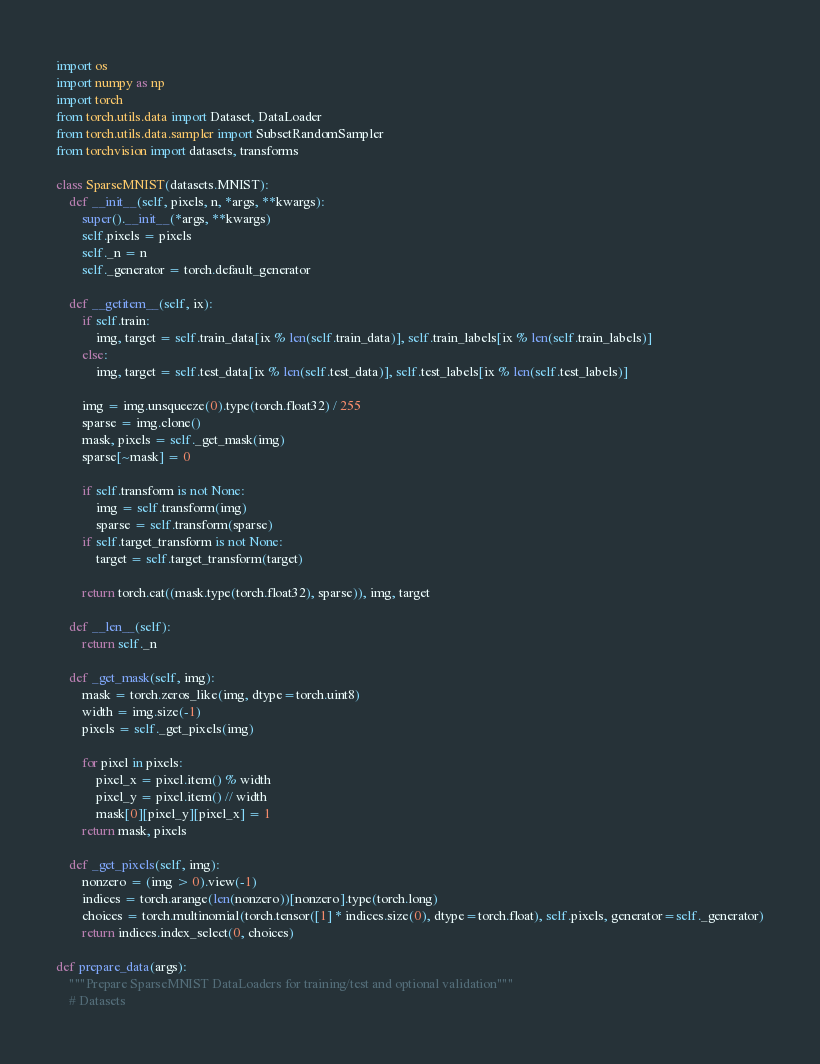Convert code to text. <code><loc_0><loc_0><loc_500><loc_500><_Python_>import os
import numpy as np
import torch
from torch.utils.data import Dataset, DataLoader
from torch.utils.data.sampler import SubsetRandomSampler
from torchvision import datasets, transforms

class SparseMNIST(datasets.MNIST):
    def __init__(self, pixels, n, *args, **kwargs):
        super().__init__(*args, **kwargs)
        self.pixels = pixels
        self._n = n
        self._generator = torch.default_generator
        
    def __getitem__(self, ix):
        if self.train:
            img, target = self.train_data[ix % len(self.train_data)], self.train_labels[ix % len(self.train_labels)]
        else:
            img, target = self.test_data[ix % len(self.test_data)], self.test_labels[ix % len(self.test_labels)]
            
        img = img.unsqueeze(0).type(torch.float32) / 255
        sparse = img.clone()
        mask, pixels = self._get_mask(img)
        sparse[~mask] = 0

        if self.transform is not None:
            img = self.transform(img)
            sparse = self.transform(sparse)
        if self.target_transform is not None:
            target = self.target_transform(target)

        return torch.cat((mask.type(torch.float32), sparse)), img, target

    def __len__(self):
        return self._n

    def _get_mask(self, img):
        mask = torch.zeros_like(img, dtype=torch.uint8)
        width = img.size(-1)
        pixels = self._get_pixels(img)
        
        for pixel in pixels:
            pixel_x = pixel.item() % width
            pixel_y = pixel.item() // width
            mask[0][pixel_y][pixel_x] = 1
        return mask, pixels

    def _get_pixels(self, img):
        nonzero = (img > 0).view(-1)
        indices = torch.arange(len(nonzero))[nonzero].type(torch.long)
        choices = torch.multinomial(torch.tensor([1] * indices.size(0), dtype=torch.float), self.pixels, generator=self._generator)
        return indices.index_select(0, choices)

def prepare_data(args):
    """Prepare SparseMNIST DataLoaders for training/test and optional validation"""
    # Datasets</code> 